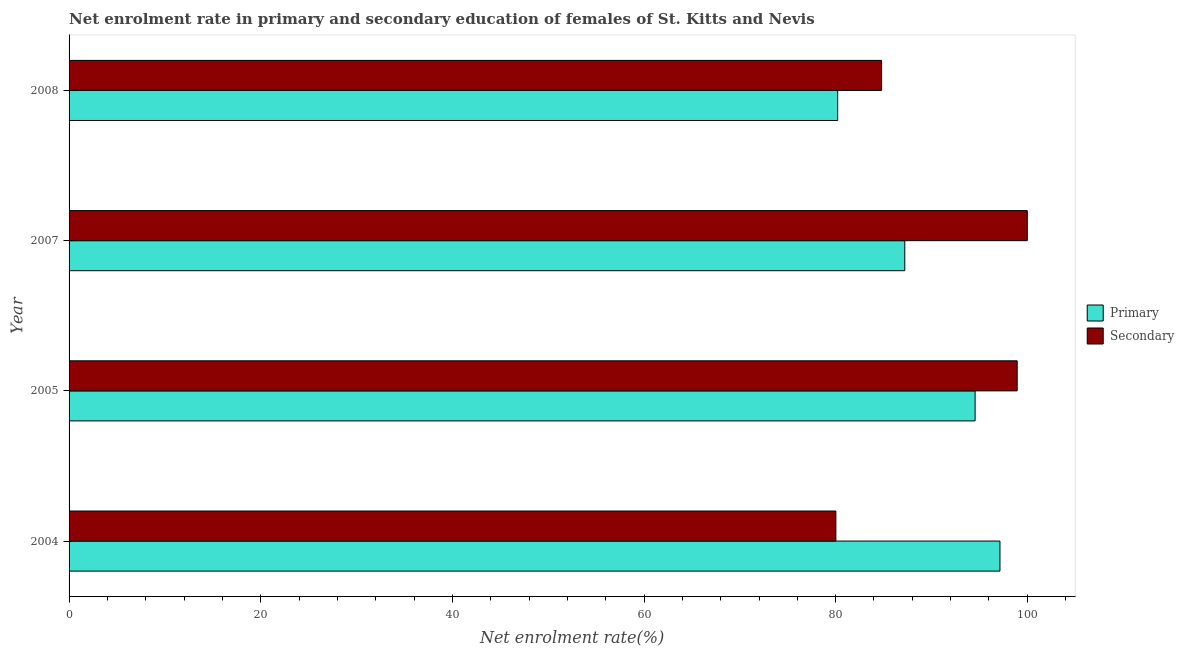How many different coloured bars are there?
Offer a very short reply. 2. Are the number of bars on each tick of the Y-axis equal?
Keep it short and to the point. Yes. How many bars are there on the 1st tick from the top?
Make the answer very short. 2. How many bars are there on the 3rd tick from the bottom?
Provide a short and direct response. 2. What is the label of the 2nd group of bars from the top?
Offer a terse response. 2007. What is the enrollment rate in primary education in 2008?
Offer a very short reply. 80.21. Across all years, what is the minimum enrollment rate in secondary education?
Make the answer very short. 80.02. In which year was the enrollment rate in primary education minimum?
Your answer should be compact. 2008. What is the total enrollment rate in primary education in the graph?
Your response must be concise. 359.13. What is the difference between the enrollment rate in secondary education in 2004 and that in 2007?
Provide a short and direct response. -19.98. What is the difference between the enrollment rate in primary education in 2005 and the enrollment rate in secondary education in 2007?
Give a very brief answer. -5.45. What is the average enrollment rate in primary education per year?
Ensure brevity in your answer.  89.78. In the year 2008, what is the difference between the enrollment rate in secondary education and enrollment rate in primary education?
Your answer should be very brief. 4.58. What is the ratio of the enrollment rate in secondary education in 2004 to that in 2005?
Give a very brief answer. 0.81. What is the difference between the highest and the second highest enrollment rate in primary education?
Give a very brief answer. 2.6. What is the difference between the highest and the lowest enrollment rate in secondary education?
Make the answer very short. 19.98. In how many years, is the enrollment rate in secondary education greater than the average enrollment rate in secondary education taken over all years?
Offer a terse response. 2. Is the sum of the enrollment rate in secondary education in 2005 and 2008 greater than the maximum enrollment rate in primary education across all years?
Offer a very short reply. Yes. What does the 2nd bar from the top in 2004 represents?
Keep it short and to the point. Primary. What does the 1st bar from the bottom in 2007 represents?
Your response must be concise. Primary. How many bars are there?
Give a very brief answer. 8. What is the difference between two consecutive major ticks on the X-axis?
Provide a short and direct response. 20. Are the values on the major ticks of X-axis written in scientific E-notation?
Offer a very short reply. No. Does the graph contain grids?
Your answer should be very brief. No. Where does the legend appear in the graph?
Your answer should be very brief. Center right. What is the title of the graph?
Provide a succinct answer. Net enrolment rate in primary and secondary education of females of St. Kitts and Nevis. What is the label or title of the X-axis?
Your response must be concise. Net enrolment rate(%). What is the label or title of the Y-axis?
Keep it short and to the point. Year. What is the Net enrolment rate(%) in Primary in 2004?
Ensure brevity in your answer.  97.15. What is the Net enrolment rate(%) of Secondary in 2004?
Provide a short and direct response. 80.02. What is the Net enrolment rate(%) of Primary in 2005?
Provide a succinct answer. 94.55. What is the Net enrolment rate(%) in Secondary in 2005?
Provide a short and direct response. 98.94. What is the Net enrolment rate(%) in Primary in 2007?
Make the answer very short. 87.21. What is the Net enrolment rate(%) in Primary in 2008?
Your response must be concise. 80.21. What is the Net enrolment rate(%) in Secondary in 2008?
Offer a terse response. 84.8. Across all years, what is the maximum Net enrolment rate(%) of Primary?
Your answer should be very brief. 97.15. Across all years, what is the minimum Net enrolment rate(%) in Primary?
Provide a succinct answer. 80.21. Across all years, what is the minimum Net enrolment rate(%) of Secondary?
Keep it short and to the point. 80.02. What is the total Net enrolment rate(%) in Primary in the graph?
Your response must be concise. 359.13. What is the total Net enrolment rate(%) in Secondary in the graph?
Provide a short and direct response. 363.76. What is the difference between the Net enrolment rate(%) in Primary in 2004 and that in 2005?
Offer a terse response. 2.59. What is the difference between the Net enrolment rate(%) in Secondary in 2004 and that in 2005?
Keep it short and to the point. -18.92. What is the difference between the Net enrolment rate(%) of Primary in 2004 and that in 2007?
Keep it short and to the point. 9.93. What is the difference between the Net enrolment rate(%) of Secondary in 2004 and that in 2007?
Make the answer very short. -19.98. What is the difference between the Net enrolment rate(%) in Primary in 2004 and that in 2008?
Your response must be concise. 16.94. What is the difference between the Net enrolment rate(%) of Secondary in 2004 and that in 2008?
Offer a terse response. -4.77. What is the difference between the Net enrolment rate(%) of Primary in 2005 and that in 2007?
Provide a short and direct response. 7.34. What is the difference between the Net enrolment rate(%) of Secondary in 2005 and that in 2007?
Your response must be concise. -1.06. What is the difference between the Net enrolment rate(%) of Primary in 2005 and that in 2008?
Offer a terse response. 14.34. What is the difference between the Net enrolment rate(%) of Secondary in 2005 and that in 2008?
Your answer should be very brief. 14.15. What is the difference between the Net enrolment rate(%) in Primary in 2007 and that in 2008?
Make the answer very short. 7. What is the difference between the Net enrolment rate(%) in Secondary in 2007 and that in 2008?
Ensure brevity in your answer.  15.2. What is the difference between the Net enrolment rate(%) of Primary in 2004 and the Net enrolment rate(%) of Secondary in 2005?
Ensure brevity in your answer.  -1.8. What is the difference between the Net enrolment rate(%) of Primary in 2004 and the Net enrolment rate(%) of Secondary in 2007?
Provide a succinct answer. -2.85. What is the difference between the Net enrolment rate(%) in Primary in 2004 and the Net enrolment rate(%) in Secondary in 2008?
Your response must be concise. 12.35. What is the difference between the Net enrolment rate(%) in Primary in 2005 and the Net enrolment rate(%) in Secondary in 2007?
Offer a terse response. -5.45. What is the difference between the Net enrolment rate(%) of Primary in 2005 and the Net enrolment rate(%) of Secondary in 2008?
Your response must be concise. 9.76. What is the difference between the Net enrolment rate(%) in Primary in 2007 and the Net enrolment rate(%) in Secondary in 2008?
Keep it short and to the point. 2.42. What is the average Net enrolment rate(%) of Primary per year?
Make the answer very short. 89.78. What is the average Net enrolment rate(%) of Secondary per year?
Make the answer very short. 90.94. In the year 2004, what is the difference between the Net enrolment rate(%) of Primary and Net enrolment rate(%) of Secondary?
Your answer should be very brief. 17.13. In the year 2005, what is the difference between the Net enrolment rate(%) of Primary and Net enrolment rate(%) of Secondary?
Give a very brief answer. -4.39. In the year 2007, what is the difference between the Net enrolment rate(%) of Primary and Net enrolment rate(%) of Secondary?
Keep it short and to the point. -12.79. In the year 2008, what is the difference between the Net enrolment rate(%) in Primary and Net enrolment rate(%) in Secondary?
Your answer should be very brief. -4.59. What is the ratio of the Net enrolment rate(%) in Primary in 2004 to that in 2005?
Your answer should be very brief. 1.03. What is the ratio of the Net enrolment rate(%) of Secondary in 2004 to that in 2005?
Make the answer very short. 0.81. What is the ratio of the Net enrolment rate(%) in Primary in 2004 to that in 2007?
Offer a very short reply. 1.11. What is the ratio of the Net enrolment rate(%) in Secondary in 2004 to that in 2007?
Ensure brevity in your answer.  0.8. What is the ratio of the Net enrolment rate(%) in Primary in 2004 to that in 2008?
Your answer should be compact. 1.21. What is the ratio of the Net enrolment rate(%) in Secondary in 2004 to that in 2008?
Your answer should be very brief. 0.94. What is the ratio of the Net enrolment rate(%) of Primary in 2005 to that in 2007?
Your response must be concise. 1.08. What is the ratio of the Net enrolment rate(%) in Primary in 2005 to that in 2008?
Your response must be concise. 1.18. What is the ratio of the Net enrolment rate(%) in Secondary in 2005 to that in 2008?
Your response must be concise. 1.17. What is the ratio of the Net enrolment rate(%) of Primary in 2007 to that in 2008?
Ensure brevity in your answer.  1.09. What is the ratio of the Net enrolment rate(%) in Secondary in 2007 to that in 2008?
Give a very brief answer. 1.18. What is the difference between the highest and the second highest Net enrolment rate(%) of Primary?
Give a very brief answer. 2.59. What is the difference between the highest and the second highest Net enrolment rate(%) in Secondary?
Make the answer very short. 1.06. What is the difference between the highest and the lowest Net enrolment rate(%) in Primary?
Offer a terse response. 16.94. What is the difference between the highest and the lowest Net enrolment rate(%) in Secondary?
Offer a terse response. 19.98. 